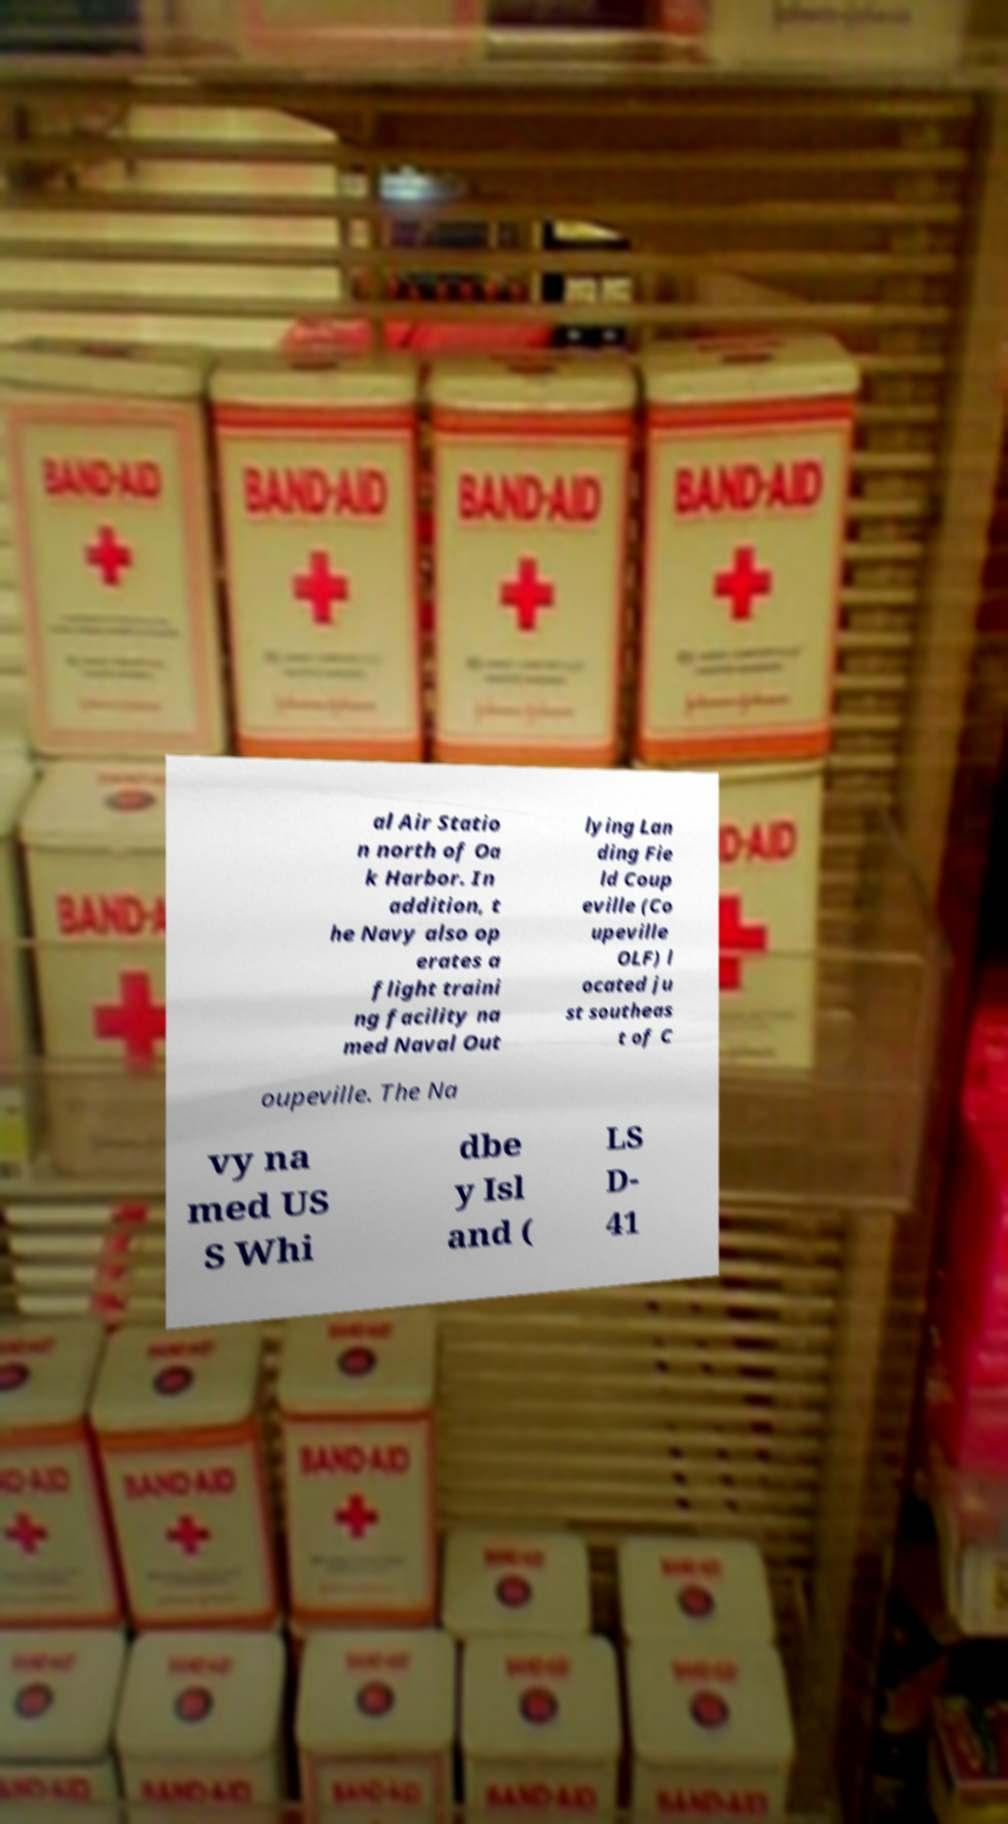Could you assist in decoding the text presented in this image and type it out clearly? al Air Statio n north of Oa k Harbor. In addition, t he Navy also op erates a flight traini ng facility na med Naval Out lying Lan ding Fie ld Coup eville (Co upeville OLF) l ocated ju st southeas t of C oupeville. The Na vy na med US S Whi dbe y Isl and ( LS D- 41 